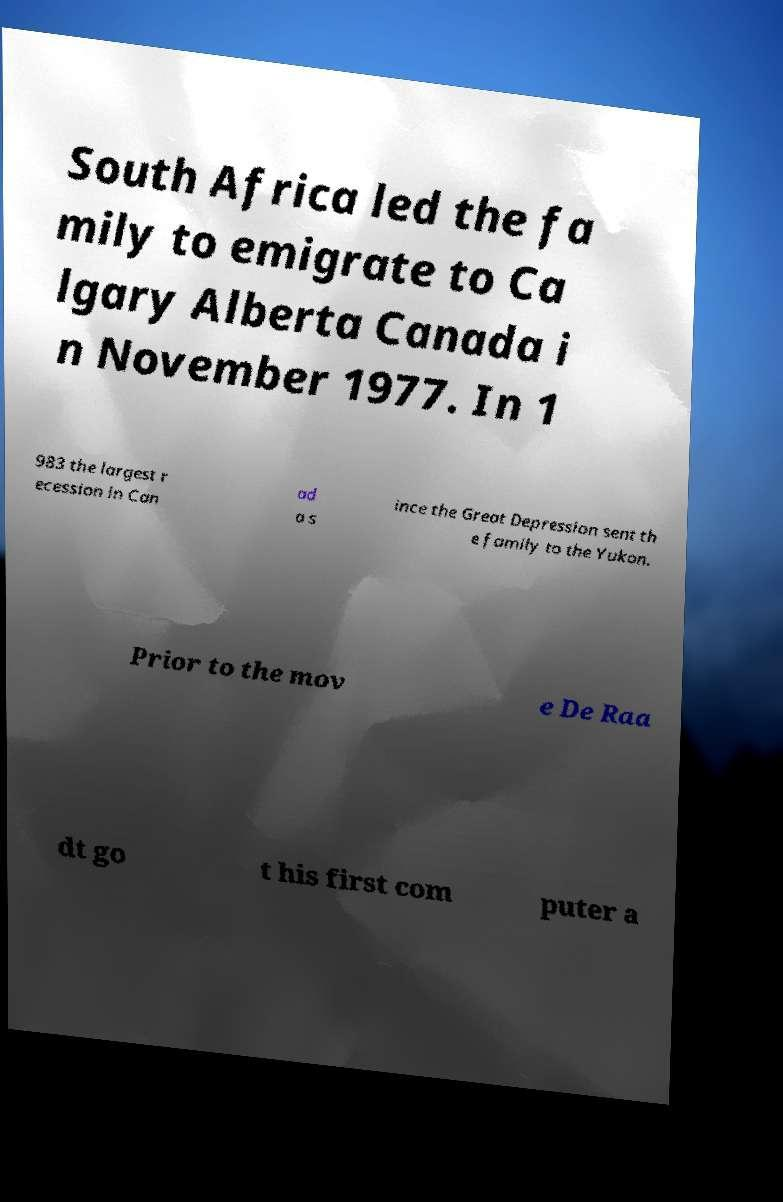Please read and relay the text visible in this image. What does it say? South Africa led the fa mily to emigrate to Ca lgary Alberta Canada i n November 1977. In 1 983 the largest r ecession in Can ad a s ince the Great Depression sent th e family to the Yukon. Prior to the mov e De Raa dt go t his first com puter a 